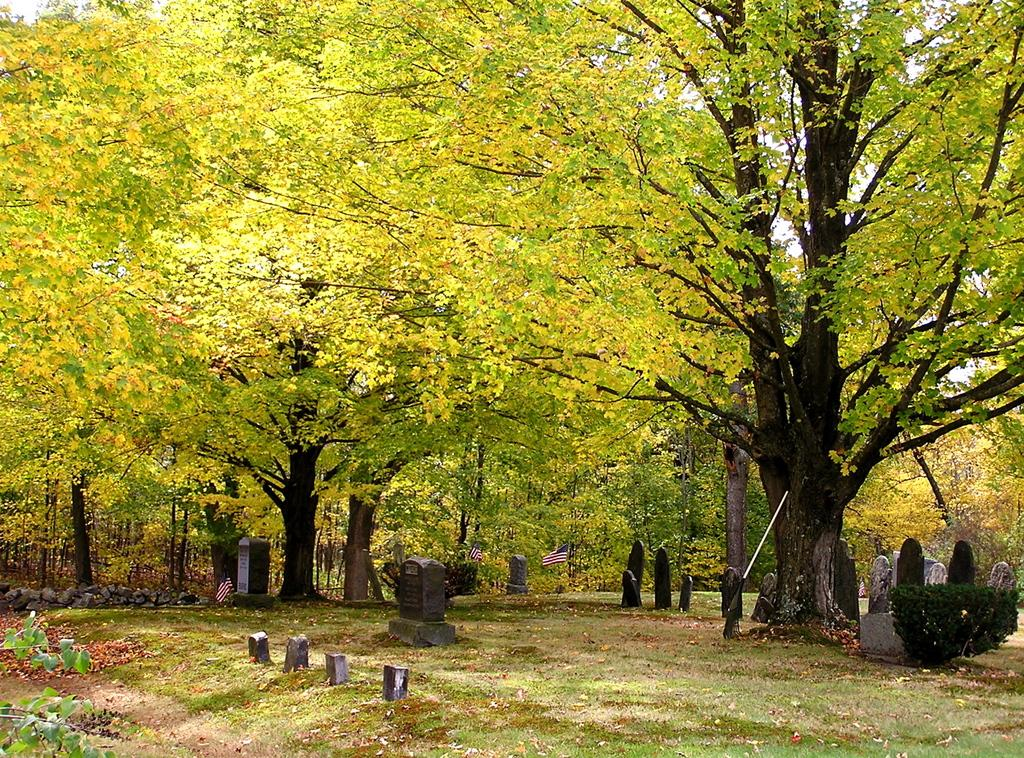What type of structures can be seen in the image? There are graves in the image. What objects are present alongside the graves? There are flags in the image. What type of vegetation is visible in the image? There are plants, grassy land, and trees in the image. What part of the natural environment is visible in the image? The sky is visible behind the trees in the image. What type of furniture can be seen in the image? There is no furniture present in the image. What color is the cap worn by the person in the image? There is no person or cap visible in the image. 